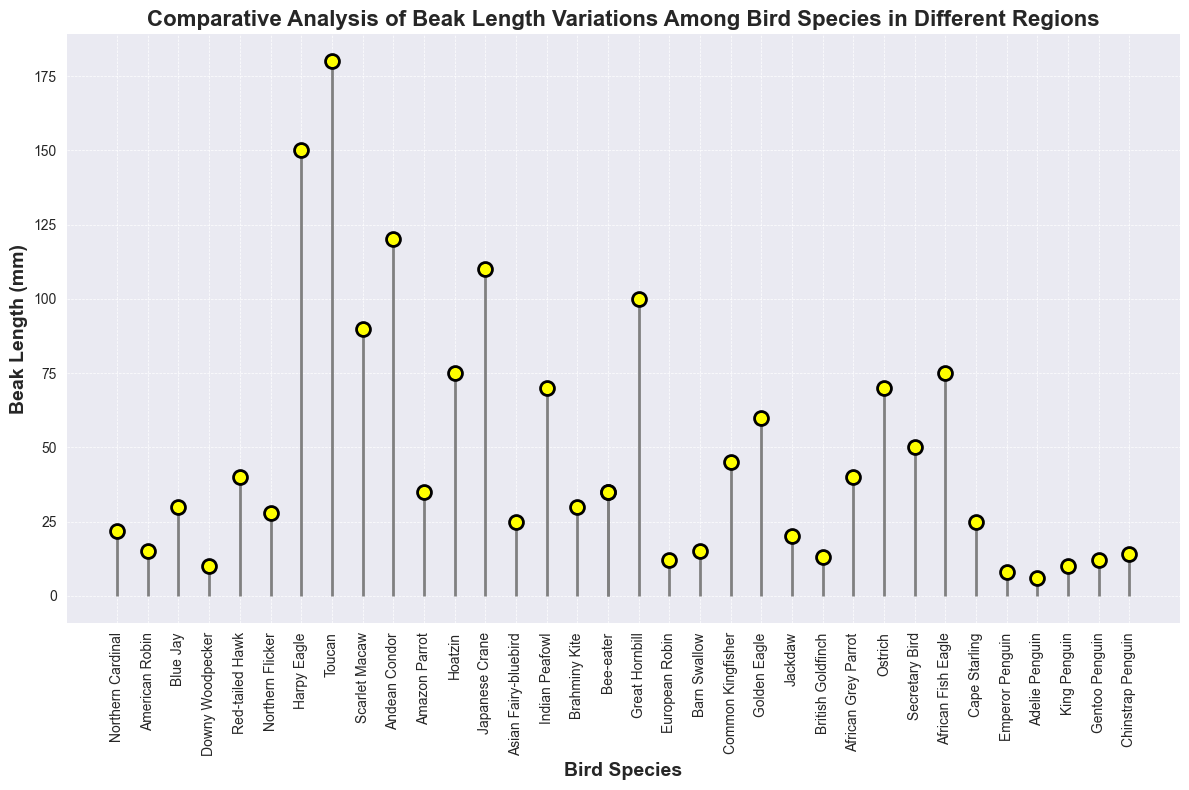Which bird species has the longest beak length in North America? By looking at the beak lengths in North America, the Red-tailed Hawk has the longest beak length at 40 mm.
Answer: Red-tailed Hawk Which bird species in Asia has the shortest beak length? By referring to the beak lengths of birds in Asia, the Asian Fairy-bluebird has the shortest beak length at 25 mm.
Answer: Asian Fairy-bluebird What's the difference in beak length between the Toucan and the Harpy Eagle in South America? The beak length of the Toucan is 180 mm and the Harpy Eagle is 150 mm. The difference is 180 mm - 150 mm = 30 mm.
Answer: 30 mm How does the beak length of the European Robin compare to the Common Kingfisher in Europe? The European Robin has a beak length of 12 mm, and the Common Kingfisher has a beak length of 45 mm. The Common Kingfisher's beak is longer.
Answer: Common Kingfisher's beak is longer Which regions have birds with beak lengths greater than 100 mm? South America has the Harpy Eagle (150 mm) and the Toucan (180 mm). Asia has the Japanese Crane (110 mm) and the Great Hornbill (100 mm). Europe is excluded. So, South America and Asia.
Answer: South America, Asia What's the average beak length of all bird species in Antarctica? The beak lengths are Emperor Penguin (8 mm), Adelie Penguin (6 mm), King Penguin (10 mm), Gentoo Penguin (12 mm), and Chinstrap Penguin (14 mm). Average = (8 + 6 + 10 + 12 + 14) / 5 = 10 mm
Answer: 10 mm If you combine the beak lengths of all bird species in North America, what's the total length? The beak lengths are 22, 15, 30, 10, 40, and 28 mm. Total = 22 + 15 + 30 + 10 + 40 + 28 = 145 mm.
Answer: 145 mm How does the median beak length of bird species in Africa compare to that in Europe? Africa's beak lengths: 40, 70, 35, 50, 75, 25. Median is 42.5 mm. Europe's beak lengths: 12, 15, 45, 60, 20, 13. Median is 17.5 mm. Africa's median is higher.
Answer: Africa's median is higher What is the beak length range for bird species in Asia? The maximum beak length is 110 mm (Japanese Crane) and the minimum is 25 mm (Asian Fairy-bluebird). Range is 110 mm - 25 mm = 85 mm.
Answer: 85 mm Are there any bird species from Antarctica with a beak length greater than 10 mm? The beak lengths of the birds in Antarctica above 10 mm are Gentoo Penguin (12 mm) and Chinstrap Penguin (14 mm).
Answer: Yes, Gentoo Penguin and Chinstrap Penguin 